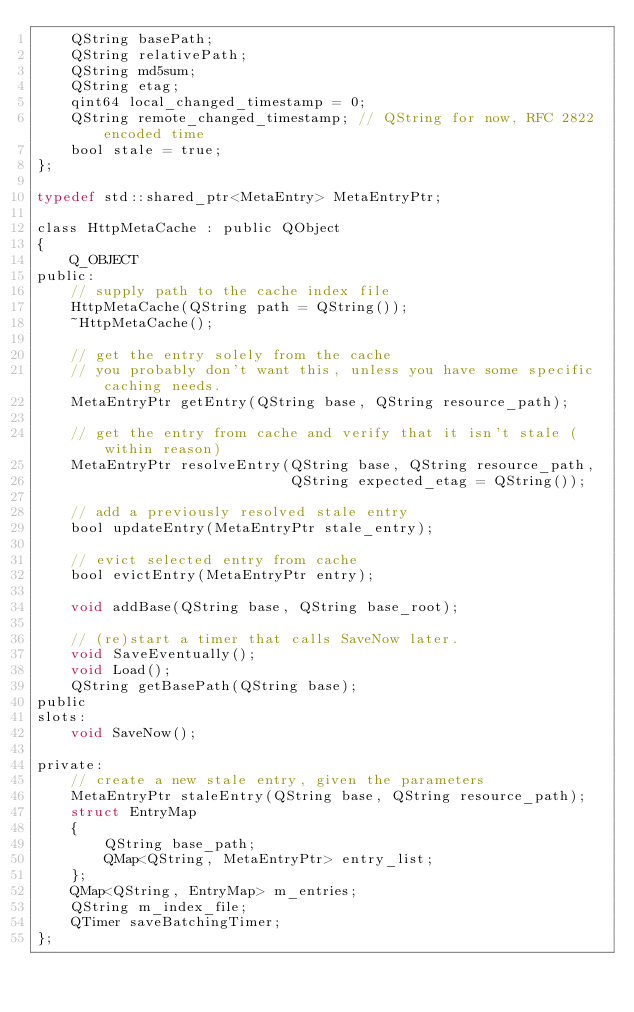<code> <loc_0><loc_0><loc_500><loc_500><_C_>    QString basePath;
    QString relativePath;
    QString md5sum;
    QString etag;
    qint64 local_changed_timestamp = 0;
    QString remote_changed_timestamp; // QString for now, RFC 2822 encoded time
    bool stale = true;
};

typedef std::shared_ptr<MetaEntry> MetaEntryPtr;

class HttpMetaCache : public QObject
{
    Q_OBJECT
public:
    // supply path to the cache index file
    HttpMetaCache(QString path = QString());
    ~HttpMetaCache();

    // get the entry solely from the cache
    // you probably don't want this, unless you have some specific caching needs.
    MetaEntryPtr getEntry(QString base, QString resource_path);

    // get the entry from cache and verify that it isn't stale (within reason)
    MetaEntryPtr resolveEntry(QString base, QString resource_path,
                              QString expected_etag = QString());

    // add a previously resolved stale entry
    bool updateEntry(MetaEntryPtr stale_entry);

    // evict selected entry from cache
    bool evictEntry(MetaEntryPtr entry);

    void addBase(QString base, QString base_root);

    // (re)start a timer that calls SaveNow later.
    void SaveEventually();
    void Load();
    QString getBasePath(QString base);
public
slots:
    void SaveNow();

private:
    // create a new stale entry, given the parameters
    MetaEntryPtr staleEntry(QString base, QString resource_path);
    struct EntryMap
    {
        QString base_path;
        QMap<QString, MetaEntryPtr> entry_list;
    };
    QMap<QString, EntryMap> m_entries;
    QString m_index_file;
    QTimer saveBatchingTimer;
};
</code> 